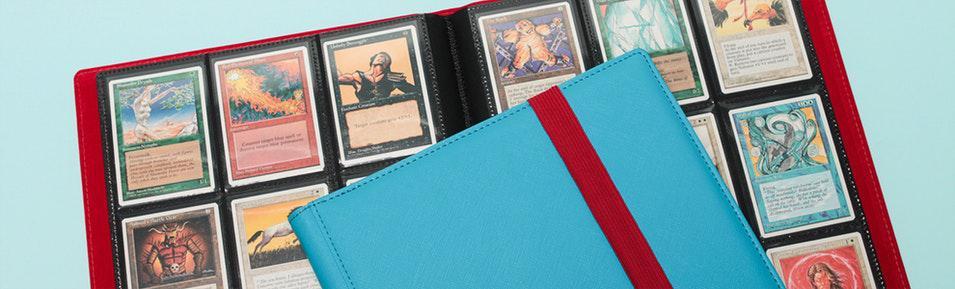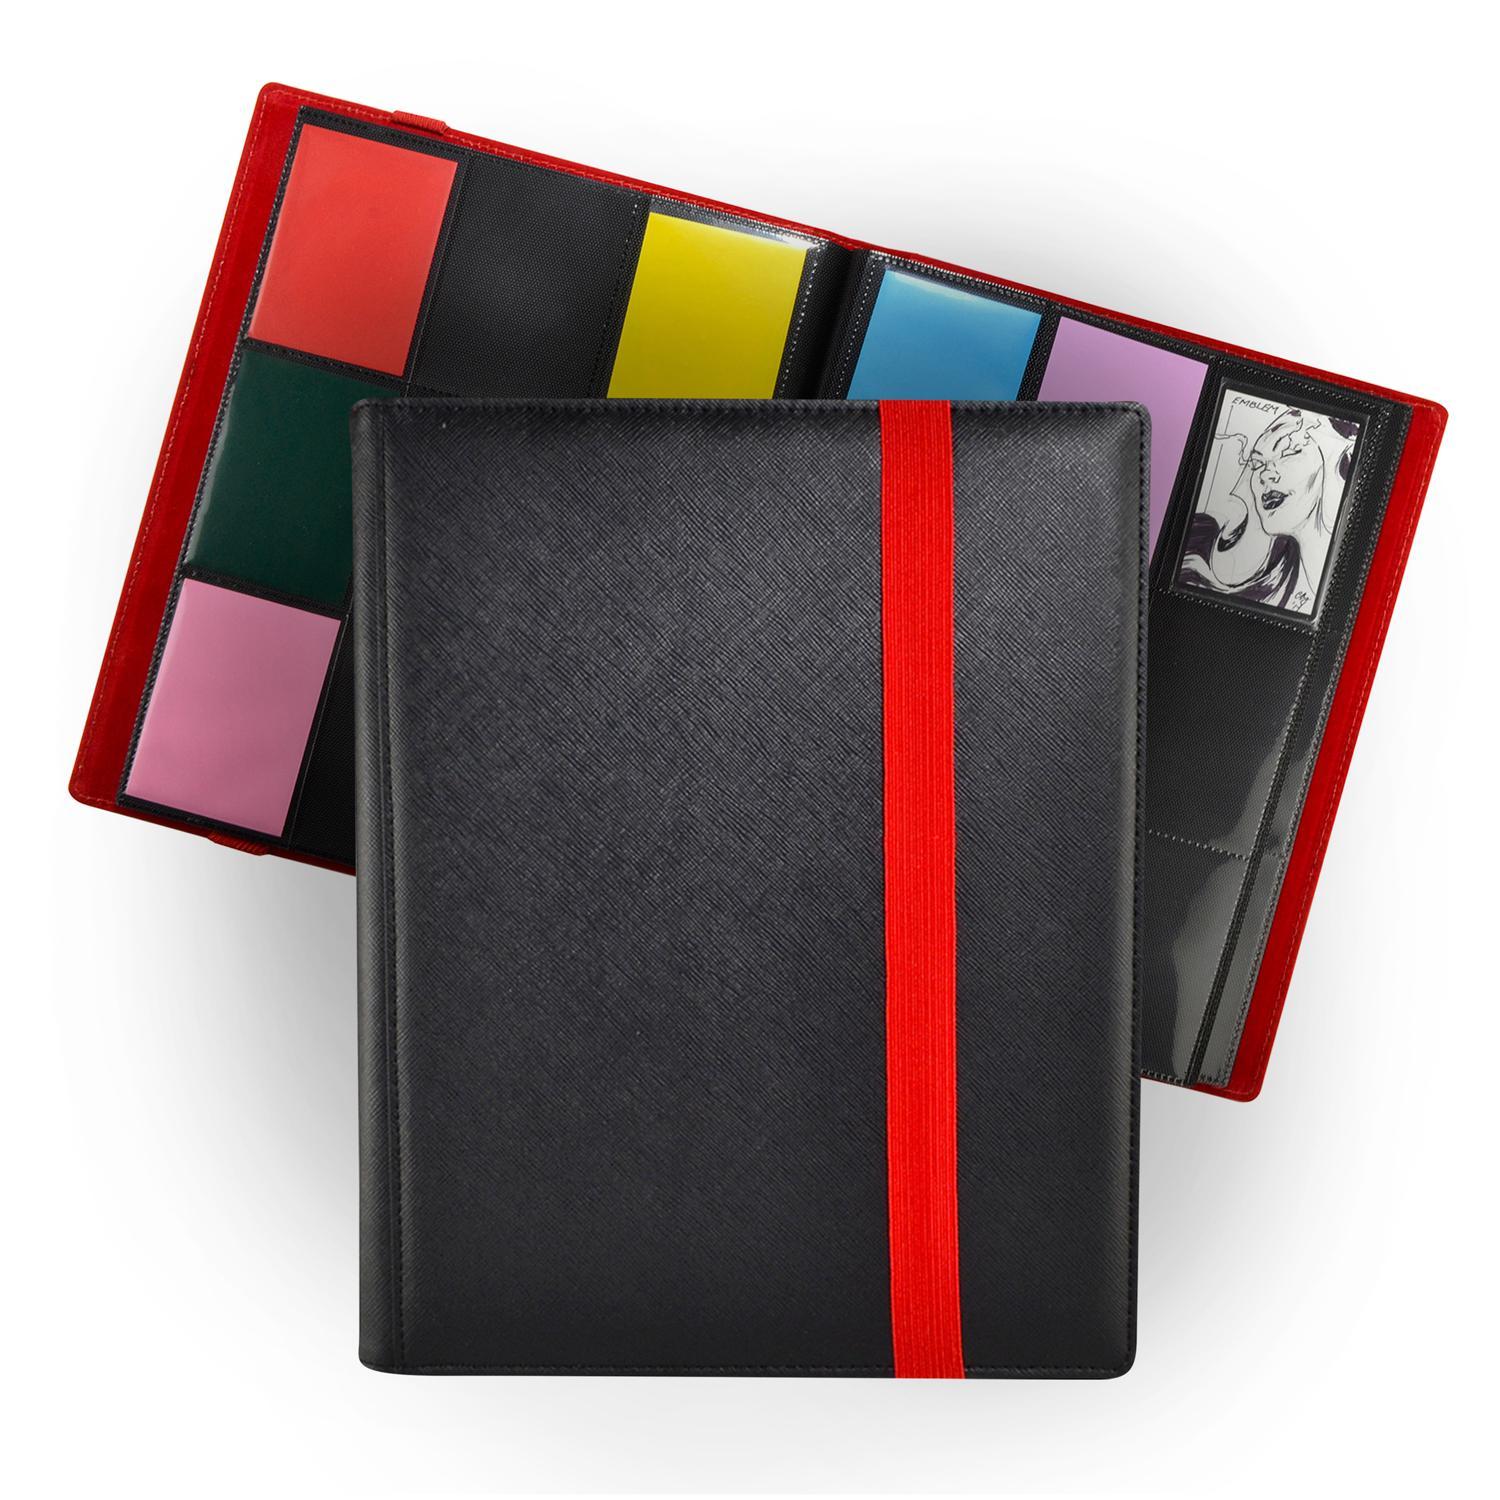The first image is the image on the left, the second image is the image on the right. Given the left and right images, does the statement "One binder is bright blue." hold true? Answer yes or no. Yes. 